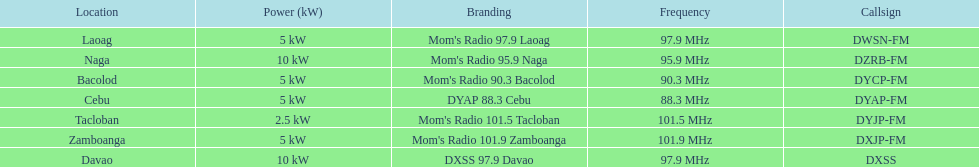Parse the table in full. {'header': ['Location', 'Power (kW)', 'Branding', 'Frequency', 'Callsign'], 'rows': [['Laoag', '5\xa0kW', "Mom's Radio 97.9 Laoag", '97.9\xa0MHz', 'DWSN-FM'], ['Naga', '10\xa0kW', "Mom's Radio 95.9 Naga", '95.9\xa0MHz', 'DZRB-FM'], ['Bacolod', '5\xa0kW', "Mom's Radio 90.3 Bacolod", '90.3\xa0MHz', 'DYCP-FM'], ['Cebu', '5\xa0kW', 'DYAP 88.3 Cebu', '88.3\xa0MHz', 'DYAP-FM'], ['Tacloban', '2.5\xa0kW', "Mom's Radio 101.5 Tacloban", '101.5\xa0MHz', 'DYJP-FM'], ['Zamboanga', '5\xa0kW', "Mom's Radio 101.9 Zamboanga", '101.9\xa0MHz', 'DXJP-FM'], ['Davao', '10\xa0kW', 'DXSS 97.9 Davao', '97.9\xa0MHz', 'DXSS']]} How many stations have at least 5 kw or more listed in the power column? 6. 